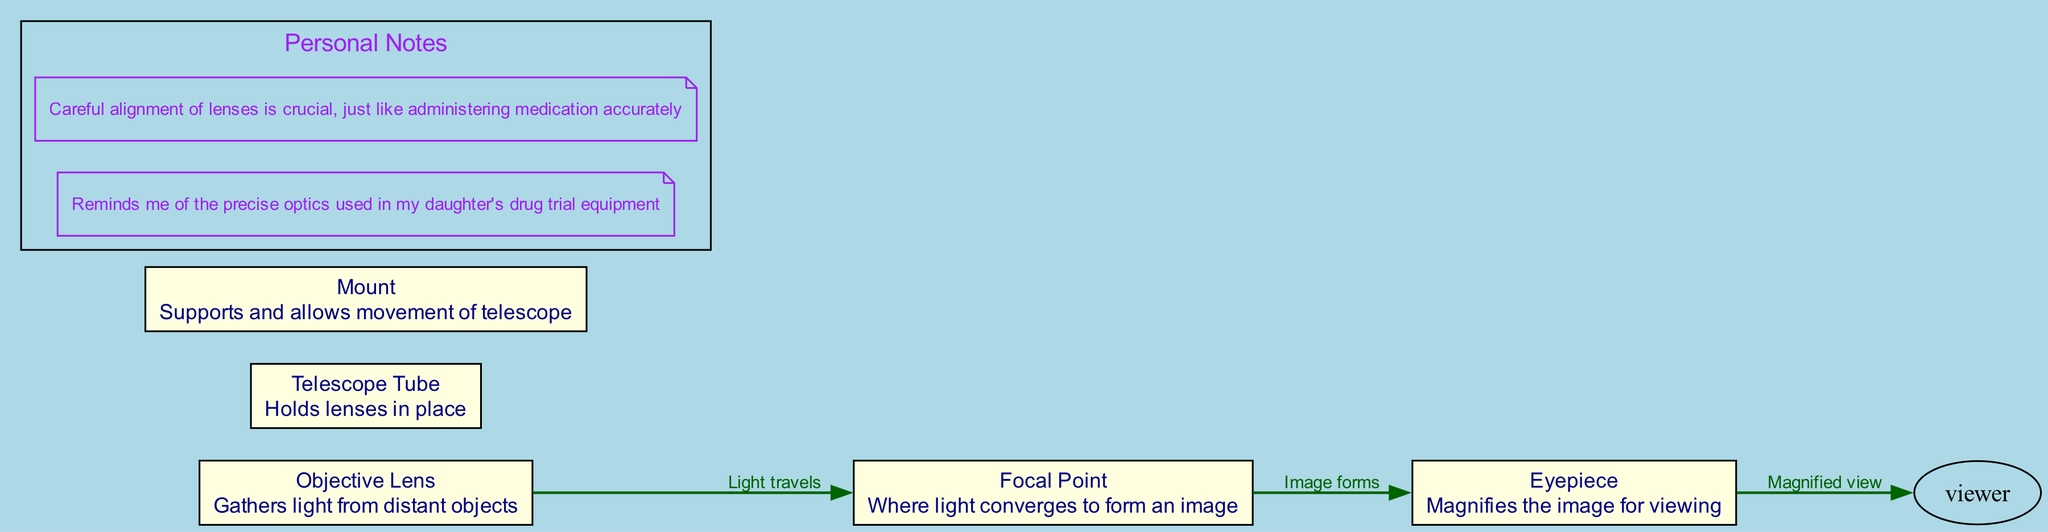What is the purpose of the objective lens? The objective lens is described as "Gathers light from distant objects." This directly answers the question about its purpose in the telescope's design.
Answer: Gathers light How many nodes are in the diagram? The diagram consists of 5 nodes: the objective lens, eyepiece, focal point, telescope tube, and mount. Counting each listed component provides the total number of nodes.
Answer: 5 What does the eyepiece do? According to the description, the eyepiece is meant to "Magnifies the image for viewing." This directly indicates the function of the eyepiece in the telescope system.
Answer: Magnifies the image What light travels from the objective lens to which point? The edge labeled "Light travels" connects the objective lens to the focal point, confirming that the light from the objective lens travels to this point in the diagram.
Answer: Focal point Where does the image form after passing through the focal point? The edge labeled "Image forms" leads from the focal point to the eyepiece, indicating that the image forms at the eyepiece after it passes through the focal point.
Answer: Eyepiece What is the relationship between the eyepiece and the viewer? The edge labeled "Magnified view" shows that light travels from the eyepiece to the viewer, establishing the relationship that the eyepiece helps produce a magnified view for the viewer.
Answer: Magnified view What supports and allows movement of the telescope? The mount is described as the component that "Supports and allows movement of telescope," directly answering what provides support in the telescope’s structure.
Answer: Mount How many edges are shown in the diagram? There are 3 edges in the diagram that represent the flow of light and image formation between the components. Counting each visual connection gives the total number of edges.
Answer: 3 What converges to form an image? The focal point is defined as "Where light converges to form an image," clearly indicating its role in the image formation process within the telescope.
Answer: Light What is crucial for telescope functionality, as noted in the personal notes? The personal notes mention that "Careful alignment of lenses is crucial," emphasizing the importance of lens alignment in ensuring the telescope functions correctly.
Answer: Alignment of lenses 